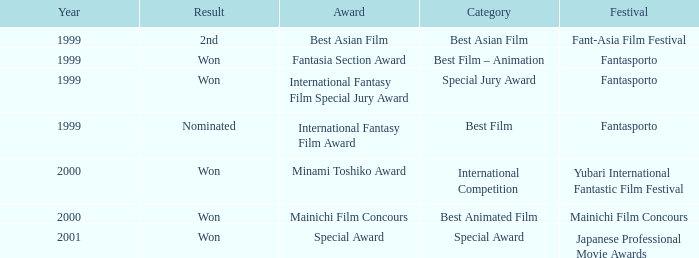What is the average year of the Fantasia Section Award? 1999.0. 